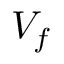Convert formula to latex. <formula><loc_0><loc_0><loc_500><loc_500>V _ { f }</formula> 